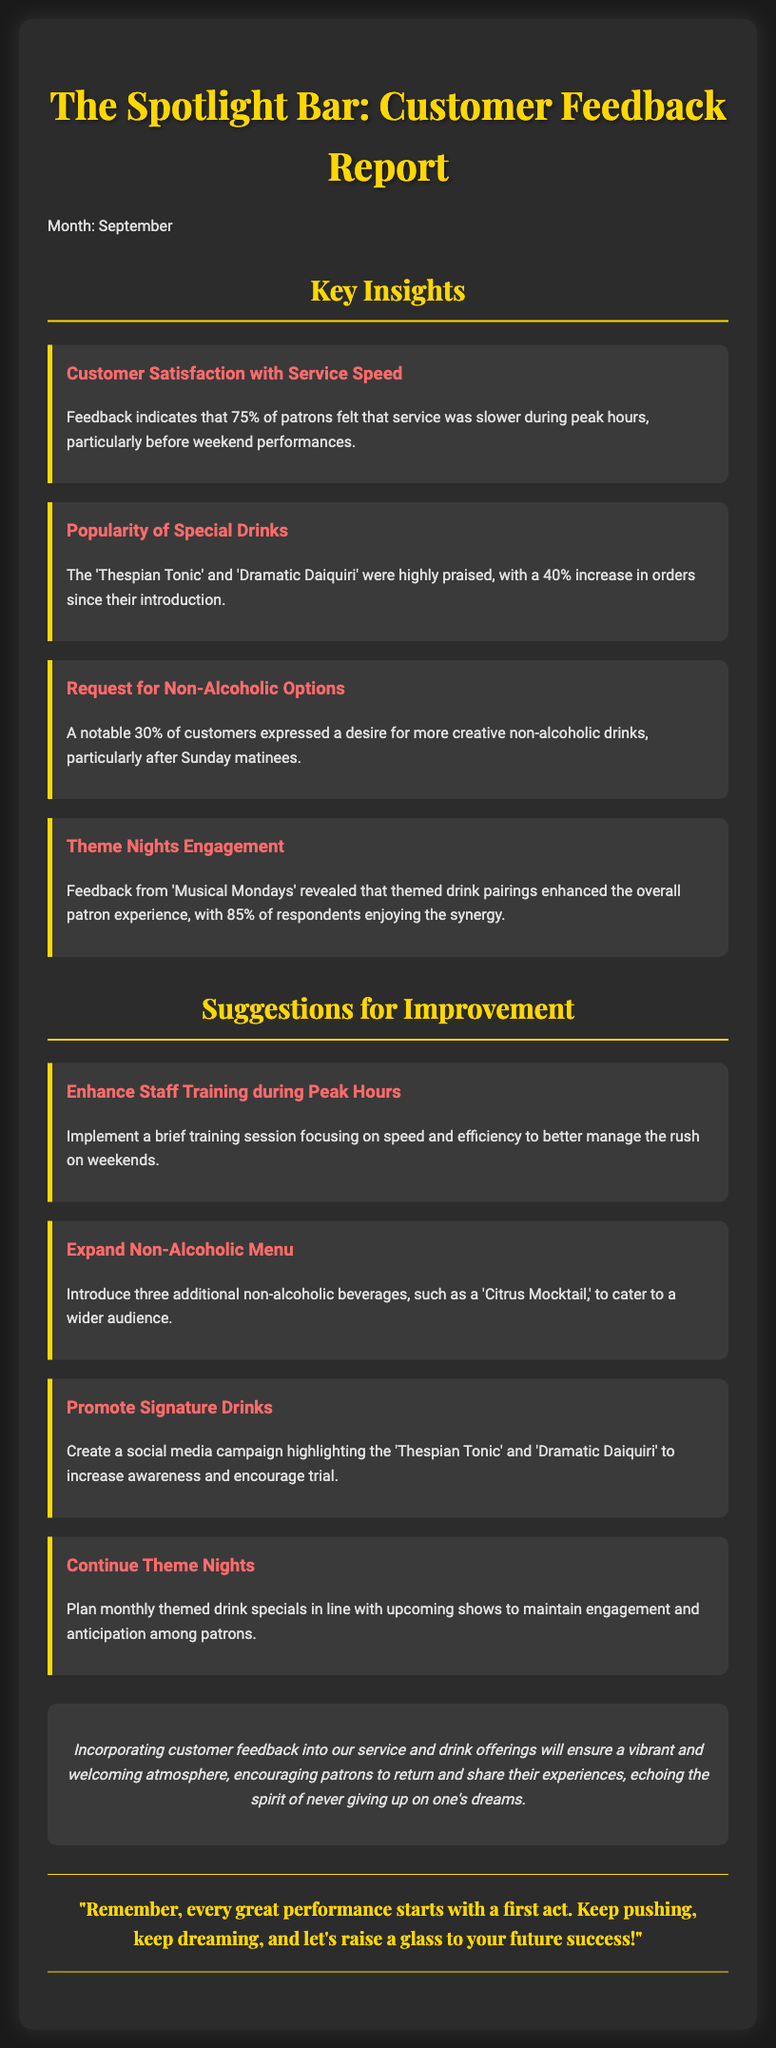What percentage of patrons experienced slow service during peak hours? The feedback indicates that 75% of patrons felt that service was slower during peak hours.
Answer: 75% What are the two highly praised special drinks? The report mentions the 'Thespian Tonic' and 'Dramatic Daiquiri' as highly praised drinks.
Answer: 'Thespian Tonic' and 'Dramatic Daiquiri' How many creative non-alcoholic drinks did 30% of customers request? The document states that 30% of customers expressed a desire for more creative non-alcoholic drinks.
Answer: More What percentage of respondents enjoyed the drink pairings during 'Musical Mondays'? Feedback revealed that 85% of respondents enjoyed the themed drink pairings.
Answer: 85% What is one suggestion for improving service speed? One suggestion is to implement a brief training session focusing on speed and efficiency.
Answer: Staff training How many additional non-alcoholic beverages are suggested to be introduced? The report suggests introducing three additional non-alcoholic beverages.
Answer: Three What campaign is suggested to promote signature drinks? The document suggests creating a social media campaign to highlight the 'Thespian Tonic' and 'Dramatic Daiquiri'.
Answer: Social media campaign What should be planned monthly according to the suggestions? The report recommends planning monthly themed drink specials in line with upcoming shows.
Answer: Theme nights 